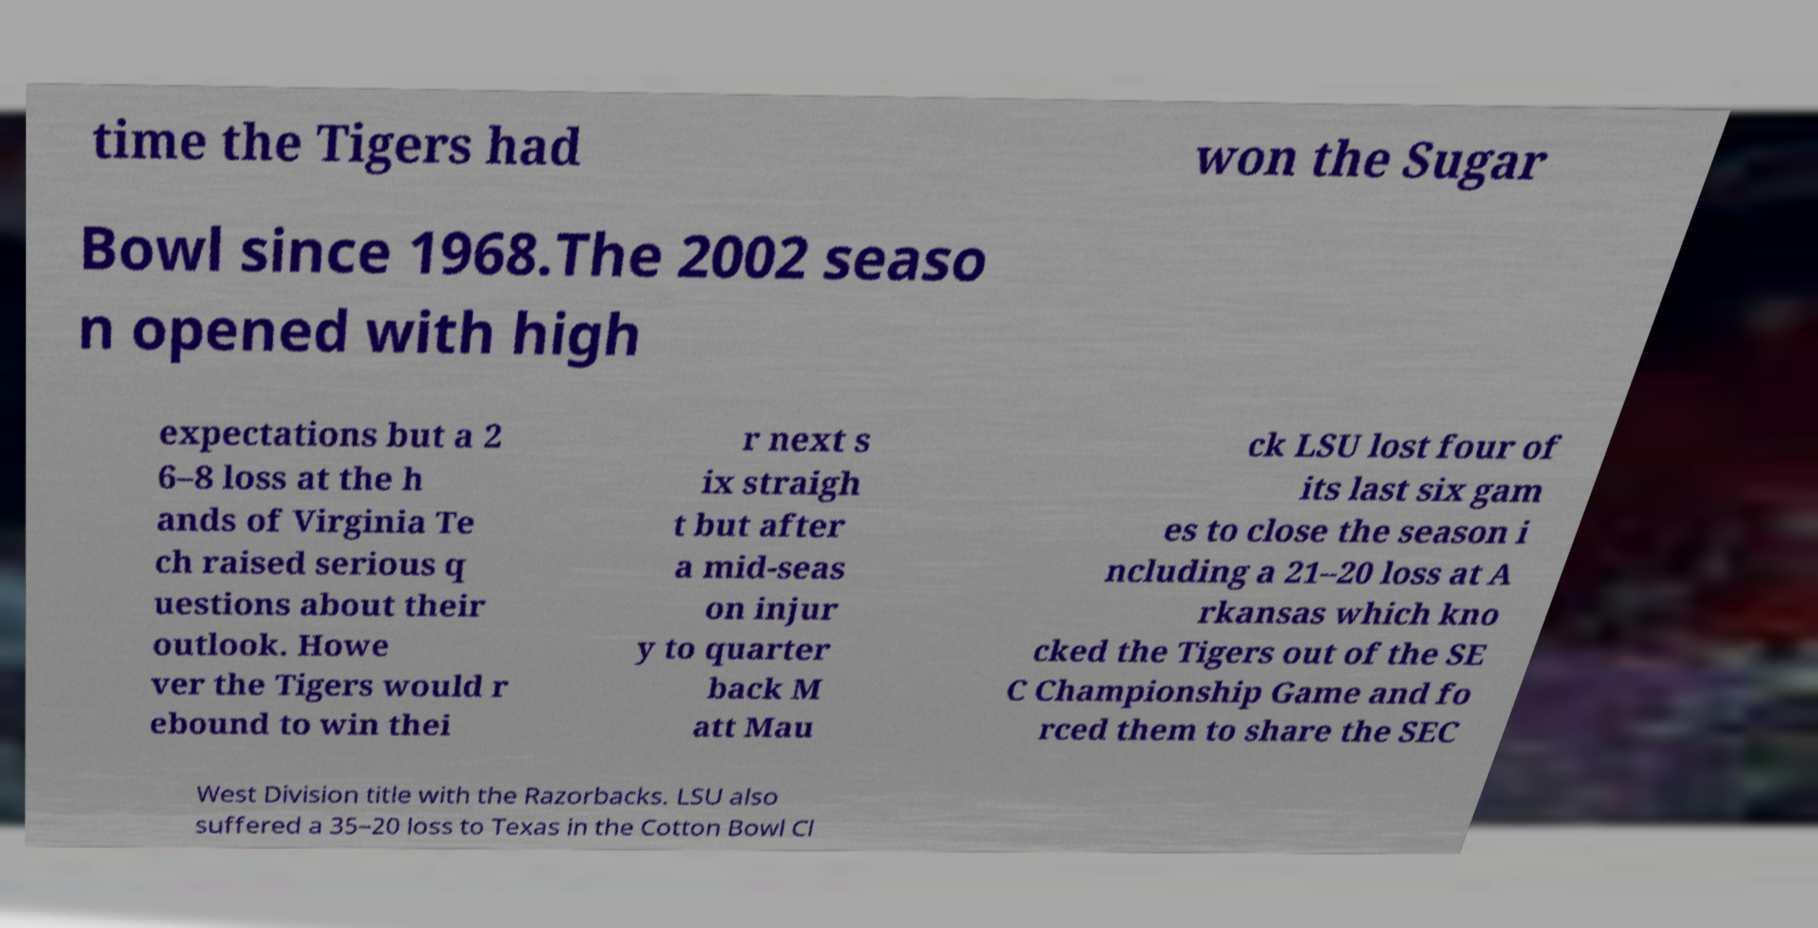Please read and relay the text visible in this image. What does it say? time the Tigers had won the Sugar Bowl since 1968.The 2002 seaso n opened with high expectations but a 2 6–8 loss at the h ands of Virginia Te ch raised serious q uestions about their outlook. Howe ver the Tigers would r ebound to win thei r next s ix straigh t but after a mid-seas on injur y to quarter back M att Mau ck LSU lost four of its last six gam es to close the season i ncluding a 21–20 loss at A rkansas which kno cked the Tigers out of the SE C Championship Game and fo rced them to share the SEC West Division title with the Razorbacks. LSU also suffered a 35–20 loss to Texas in the Cotton Bowl Cl 